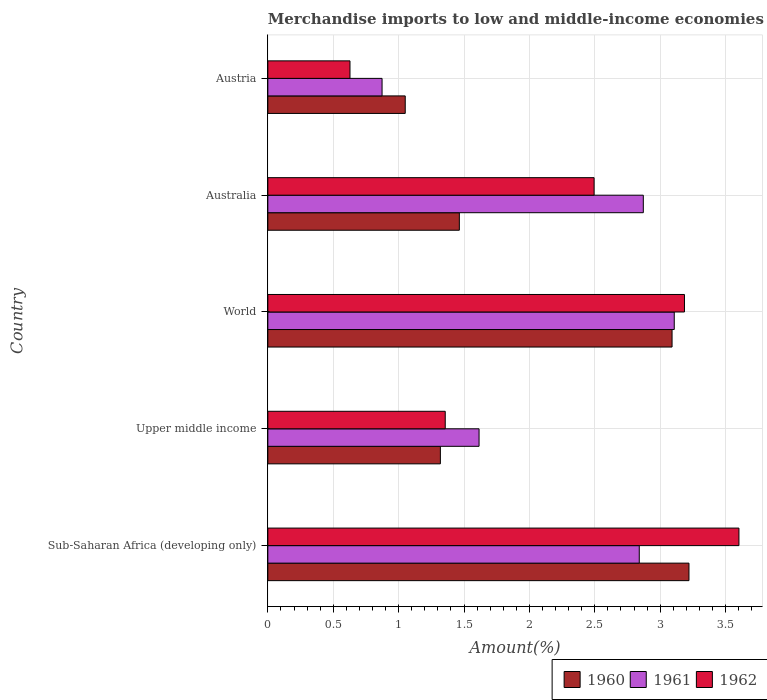How many different coloured bars are there?
Make the answer very short. 3. How many bars are there on the 2nd tick from the bottom?
Keep it short and to the point. 3. What is the label of the 2nd group of bars from the top?
Offer a very short reply. Australia. In how many cases, is the number of bars for a given country not equal to the number of legend labels?
Offer a very short reply. 0. What is the percentage of amount earned from merchandise imports in 1962 in Upper middle income?
Your answer should be very brief. 1.36. Across all countries, what is the maximum percentage of amount earned from merchandise imports in 1961?
Provide a succinct answer. 3.11. Across all countries, what is the minimum percentage of amount earned from merchandise imports in 1962?
Ensure brevity in your answer.  0.63. In which country was the percentage of amount earned from merchandise imports in 1960 minimum?
Ensure brevity in your answer.  Austria. What is the total percentage of amount earned from merchandise imports in 1961 in the graph?
Make the answer very short. 11.31. What is the difference between the percentage of amount earned from merchandise imports in 1960 in Australia and that in Austria?
Ensure brevity in your answer.  0.41. What is the difference between the percentage of amount earned from merchandise imports in 1960 in Upper middle income and the percentage of amount earned from merchandise imports in 1962 in Sub-Saharan Africa (developing only)?
Your answer should be compact. -2.28. What is the average percentage of amount earned from merchandise imports in 1961 per country?
Offer a very short reply. 2.26. What is the difference between the percentage of amount earned from merchandise imports in 1962 and percentage of amount earned from merchandise imports in 1960 in World?
Offer a very short reply. 0.09. In how many countries, is the percentage of amount earned from merchandise imports in 1962 greater than 2.3 %?
Offer a very short reply. 3. What is the ratio of the percentage of amount earned from merchandise imports in 1960 in Australia to that in Sub-Saharan Africa (developing only)?
Make the answer very short. 0.45. Is the difference between the percentage of amount earned from merchandise imports in 1962 in Australia and Upper middle income greater than the difference between the percentage of amount earned from merchandise imports in 1960 in Australia and Upper middle income?
Provide a succinct answer. Yes. What is the difference between the highest and the second highest percentage of amount earned from merchandise imports in 1962?
Provide a succinct answer. 0.42. What is the difference between the highest and the lowest percentage of amount earned from merchandise imports in 1961?
Your answer should be very brief. 2.23. What does the 3rd bar from the bottom in Australia represents?
Your response must be concise. 1962. How many bars are there?
Keep it short and to the point. 15. Are all the bars in the graph horizontal?
Your response must be concise. Yes. What is the difference between two consecutive major ticks on the X-axis?
Keep it short and to the point. 0.5. Are the values on the major ticks of X-axis written in scientific E-notation?
Ensure brevity in your answer.  No. Does the graph contain any zero values?
Provide a short and direct response. No. Where does the legend appear in the graph?
Make the answer very short. Bottom right. How many legend labels are there?
Your answer should be very brief. 3. How are the legend labels stacked?
Keep it short and to the point. Horizontal. What is the title of the graph?
Keep it short and to the point. Merchandise imports to low and middle-income economies in North Africa. What is the label or title of the X-axis?
Offer a very short reply. Amount(%). What is the label or title of the Y-axis?
Offer a very short reply. Country. What is the Amount(%) in 1960 in Sub-Saharan Africa (developing only)?
Keep it short and to the point. 3.22. What is the Amount(%) in 1961 in Sub-Saharan Africa (developing only)?
Your answer should be very brief. 2.84. What is the Amount(%) of 1962 in Sub-Saharan Africa (developing only)?
Provide a short and direct response. 3.6. What is the Amount(%) in 1960 in Upper middle income?
Keep it short and to the point. 1.32. What is the Amount(%) in 1961 in Upper middle income?
Your answer should be very brief. 1.62. What is the Amount(%) in 1962 in Upper middle income?
Keep it short and to the point. 1.36. What is the Amount(%) of 1960 in World?
Keep it short and to the point. 3.09. What is the Amount(%) in 1961 in World?
Your response must be concise. 3.11. What is the Amount(%) of 1962 in World?
Your answer should be very brief. 3.19. What is the Amount(%) of 1960 in Australia?
Make the answer very short. 1.46. What is the Amount(%) of 1961 in Australia?
Keep it short and to the point. 2.87. What is the Amount(%) in 1962 in Australia?
Provide a succinct answer. 2.49. What is the Amount(%) of 1960 in Austria?
Give a very brief answer. 1.05. What is the Amount(%) in 1961 in Austria?
Make the answer very short. 0.87. What is the Amount(%) in 1962 in Austria?
Provide a succinct answer. 0.63. Across all countries, what is the maximum Amount(%) in 1960?
Make the answer very short. 3.22. Across all countries, what is the maximum Amount(%) in 1961?
Your response must be concise. 3.11. Across all countries, what is the maximum Amount(%) of 1962?
Give a very brief answer. 3.6. Across all countries, what is the minimum Amount(%) of 1960?
Ensure brevity in your answer.  1.05. Across all countries, what is the minimum Amount(%) of 1961?
Offer a very short reply. 0.87. Across all countries, what is the minimum Amount(%) of 1962?
Give a very brief answer. 0.63. What is the total Amount(%) of 1960 in the graph?
Your answer should be very brief. 10.14. What is the total Amount(%) of 1961 in the graph?
Your response must be concise. 11.31. What is the total Amount(%) of 1962 in the graph?
Your answer should be very brief. 11.27. What is the difference between the Amount(%) of 1960 in Sub-Saharan Africa (developing only) and that in Upper middle income?
Make the answer very short. 1.9. What is the difference between the Amount(%) of 1961 in Sub-Saharan Africa (developing only) and that in Upper middle income?
Ensure brevity in your answer.  1.23. What is the difference between the Amount(%) in 1962 in Sub-Saharan Africa (developing only) and that in Upper middle income?
Give a very brief answer. 2.25. What is the difference between the Amount(%) in 1960 in Sub-Saharan Africa (developing only) and that in World?
Make the answer very short. 0.13. What is the difference between the Amount(%) in 1961 in Sub-Saharan Africa (developing only) and that in World?
Ensure brevity in your answer.  -0.27. What is the difference between the Amount(%) in 1962 in Sub-Saharan Africa (developing only) and that in World?
Give a very brief answer. 0.42. What is the difference between the Amount(%) of 1960 in Sub-Saharan Africa (developing only) and that in Australia?
Your answer should be very brief. 1.76. What is the difference between the Amount(%) in 1961 in Sub-Saharan Africa (developing only) and that in Australia?
Your answer should be very brief. -0.03. What is the difference between the Amount(%) in 1962 in Sub-Saharan Africa (developing only) and that in Australia?
Your answer should be compact. 1.11. What is the difference between the Amount(%) of 1960 in Sub-Saharan Africa (developing only) and that in Austria?
Give a very brief answer. 2.17. What is the difference between the Amount(%) of 1961 in Sub-Saharan Africa (developing only) and that in Austria?
Give a very brief answer. 1.97. What is the difference between the Amount(%) of 1962 in Sub-Saharan Africa (developing only) and that in Austria?
Provide a short and direct response. 2.97. What is the difference between the Amount(%) of 1960 in Upper middle income and that in World?
Give a very brief answer. -1.77. What is the difference between the Amount(%) in 1961 in Upper middle income and that in World?
Offer a terse response. -1.49. What is the difference between the Amount(%) of 1962 in Upper middle income and that in World?
Give a very brief answer. -1.83. What is the difference between the Amount(%) of 1960 in Upper middle income and that in Australia?
Give a very brief answer. -0.14. What is the difference between the Amount(%) of 1961 in Upper middle income and that in Australia?
Provide a short and direct response. -1.26. What is the difference between the Amount(%) of 1962 in Upper middle income and that in Australia?
Make the answer very short. -1.14. What is the difference between the Amount(%) of 1960 in Upper middle income and that in Austria?
Your response must be concise. 0.27. What is the difference between the Amount(%) of 1961 in Upper middle income and that in Austria?
Give a very brief answer. 0.74. What is the difference between the Amount(%) in 1962 in Upper middle income and that in Austria?
Provide a short and direct response. 0.73. What is the difference between the Amount(%) in 1960 in World and that in Australia?
Offer a terse response. 1.63. What is the difference between the Amount(%) of 1961 in World and that in Australia?
Keep it short and to the point. 0.24. What is the difference between the Amount(%) of 1962 in World and that in Australia?
Give a very brief answer. 0.69. What is the difference between the Amount(%) of 1960 in World and that in Austria?
Ensure brevity in your answer.  2.04. What is the difference between the Amount(%) of 1961 in World and that in Austria?
Your answer should be very brief. 2.23. What is the difference between the Amount(%) in 1962 in World and that in Austria?
Keep it short and to the point. 2.56. What is the difference between the Amount(%) of 1960 in Australia and that in Austria?
Offer a very short reply. 0.41. What is the difference between the Amount(%) of 1961 in Australia and that in Austria?
Your answer should be compact. 2. What is the difference between the Amount(%) in 1962 in Australia and that in Austria?
Your answer should be very brief. 1.87. What is the difference between the Amount(%) in 1960 in Sub-Saharan Africa (developing only) and the Amount(%) in 1961 in Upper middle income?
Offer a very short reply. 1.61. What is the difference between the Amount(%) in 1960 in Sub-Saharan Africa (developing only) and the Amount(%) in 1962 in Upper middle income?
Ensure brevity in your answer.  1.86. What is the difference between the Amount(%) of 1961 in Sub-Saharan Africa (developing only) and the Amount(%) of 1962 in Upper middle income?
Your answer should be very brief. 1.48. What is the difference between the Amount(%) of 1960 in Sub-Saharan Africa (developing only) and the Amount(%) of 1961 in World?
Offer a very short reply. 0.11. What is the difference between the Amount(%) in 1960 in Sub-Saharan Africa (developing only) and the Amount(%) in 1962 in World?
Your answer should be compact. 0.03. What is the difference between the Amount(%) in 1961 in Sub-Saharan Africa (developing only) and the Amount(%) in 1962 in World?
Your answer should be compact. -0.35. What is the difference between the Amount(%) of 1960 in Sub-Saharan Africa (developing only) and the Amount(%) of 1961 in Australia?
Offer a terse response. 0.35. What is the difference between the Amount(%) in 1960 in Sub-Saharan Africa (developing only) and the Amount(%) in 1962 in Australia?
Ensure brevity in your answer.  0.73. What is the difference between the Amount(%) of 1961 in Sub-Saharan Africa (developing only) and the Amount(%) of 1962 in Australia?
Offer a terse response. 0.35. What is the difference between the Amount(%) of 1960 in Sub-Saharan Africa (developing only) and the Amount(%) of 1961 in Austria?
Make the answer very short. 2.35. What is the difference between the Amount(%) in 1960 in Sub-Saharan Africa (developing only) and the Amount(%) in 1962 in Austria?
Your answer should be compact. 2.59. What is the difference between the Amount(%) in 1961 in Sub-Saharan Africa (developing only) and the Amount(%) in 1962 in Austria?
Provide a succinct answer. 2.21. What is the difference between the Amount(%) of 1960 in Upper middle income and the Amount(%) of 1961 in World?
Your answer should be very brief. -1.79. What is the difference between the Amount(%) of 1960 in Upper middle income and the Amount(%) of 1962 in World?
Make the answer very short. -1.87. What is the difference between the Amount(%) of 1961 in Upper middle income and the Amount(%) of 1962 in World?
Your response must be concise. -1.57. What is the difference between the Amount(%) in 1960 in Upper middle income and the Amount(%) in 1961 in Australia?
Give a very brief answer. -1.55. What is the difference between the Amount(%) of 1960 in Upper middle income and the Amount(%) of 1962 in Australia?
Your answer should be very brief. -1.18. What is the difference between the Amount(%) of 1961 in Upper middle income and the Amount(%) of 1962 in Australia?
Give a very brief answer. -0.88. What is the difference between the Amount(%) in 1960 in Upper middle income and the Amount(%) in 1961 in Austria?
Your response must be concise. 0.45. What is the difference between the Amount(%) in 1960 in Upper middle income and the Amount(%) in 1962 in Austria?
Provide a succinct answer. 0.69. What is the difference between the Amount(%) in 1961 in Upper middle income and the Amount(%) in 1962 in Austria?
Provide a succinct answer. 0.99. What is the difference between the Amount(%) in 1960 in World and the Amount(%) in 1961 in Australia?
Make the answer very short. 0.22. What is the difference between the Amount(%) of 1960 in World and the Amount(%) of 1962 in Australia?
Your answer should be very brief. 0.6. What is the difference between the Amount(%) in 1961 in World and the Amount(%) in 1962 in Australia?
Offer a terse response. 0.61. What is the difference between the Amount(%) in 1960 in World and the Amount(%) in 1961 in Austria?
Make the answer very short. 2.22. What is the difference between the Amount(%) in 1960 in World and the Amount(%) in 1962 in Austria?
Ensure brevity in your answer.  2.46. What is the difference between the Amount(%) in 1961 in World and the Amount(%) in 1962 in Austria?
Keep it short and to the point. 2.48. What is the difference between the Amount(%) in 1960 in Australia and the Amount(%) in 1961 in Austria?
Your answer should be very brief. 0.59. What is the difference between the Amount(%) of 1960 in Australia and the Amount(%) of 1962 in Austria?
Your answer should be compact. 0.84. What is the difference between the Amount(%) in 1961 in Australia and the Amount(%) in 1962 in Austria?
Offer a very short reply. 2.24. What is the average Amount(%) in 1960 per country?
Provide a short and direct response. 2.03. What is the average Amount(%) in 1961 per country?
Offer a terse response. 2.26. What is the average Amount(%) of 1962 per country?
Your answer should be very brief. 2.25. What is the difference between the Amount(%) in 1960 and Amount(%) in 1961 in Sub-Saharan Africa (developing only)?
Provide a short and direct response. 0.38. What is the difference between the Amount(%) of 1960 and Amount(%) of 1962 in Sub-Saharan Africa (developing only)?
Provide a short and direct response. -0.38. What is the difference between the Amount(%) of 1961 and Amount(%) of 1962 in Sub-Saharan Africa (developing only)?
Make the answer very short. -0.76. What is the difference between the Amount(%) of 1960 and Amount(%) of 1961 in Upper middle income?
Provide a succinct answer. -0.3. What is the difference between the Amount(%) of 1960 and Amount(%) of 1962 in Upper middle income?
Give a very brief answer. -0.04. What is the difference between the Amount(%) of 1961 and Amount(%) of 1962 in Upper middle income?
Your answer should be compact. 0.26. What is the difference between the Amount(%) of 1960 and Amount(%) of 1961 in World?
Your answer should be compact. -0.02. What is the difference between the Amount(%) in 1960 and Amount(%) in 1962 in World?
Your answer should be compact. -0.1. What is the difference between the Amount(%) of 1961 and Amount(%) of 1962 in World?
Make the answer very short. -0.08. What is the difference between the Amount(%) of 1960 and Amount(%) of 1961 in Australia?
Offer a terse response. -1.41. What is the difference between the Amount(%) of 1960 and Amount(%) of 1962 in Australia?
Give a very brief answer. -1.03. What is the difference between the Amount(%) in 1961 and Amount(%) in 1962 in Australia?
Your answer should be compact. 0.38. What is the difference between the Amount(%) of 1960 and Amount(%) of 1961 in Austria?
Provide a short and direct response. 0.18. What is the difference between the Amount(%) in 1960 and Amount(%) in 1962 in Austria?
Offer a terse response. 0.42. What is the difference between the Amount(%) of 1961 and Amount(%) of 1962 in Austria?
Offer a very short reply. 0.25. What is the ratio of the Amount(%) in 1960 in Sub-Saharan Africa (developing only) to that in Upper middle income?
Your answer should be very brief. 2.44. What is the ratio of the Amount(%) of 1961 in Sub-Saharan Africa (developing only) to that in Upper middle income?
Your answer should be compact. 1.76. What is the ratio of the Amount(%) of 1962 in Sub-Saharan Africa (developing only) to that in Upper middle income?
Offer a terse response. 2.66. What is the ratio of the Amount(%) of 1960 in Sub-Saharan Africa (developing only) to that in World?
Offer a terse response. 1.04. What is the ratio of the Amount(%) in 1961 in Sub-Saharan Africa (developing only) to that in World?
Make the answer very short. 0.91. What is the ratio of the Amount(%) in 1962 in Sub-Saharan Africa (developing only) to that in World?
Make the answer very short. 1.13. What is the ratio of the Amount(%) of 1960 in Sub-Saharan Africa (developing only) to that in Australia?
Your response must be concise. 2.2. What is the ratio of the Amount(%) in 1962 in Sub-Saharan Africa (developing only) to that in Australia?
Offer a terse response. 1.44. What is the ratio of the Amount(%) of 1960 in Sub-Saharan Africa (developing only) to that in Austria?
Your answer should be very brief. 3.07. What is the ratio of the Amount(%) of 1961 in Sub-Saharan Africa (developing only) to that in Austria?
Your answer should be compact. 3.25. What is the ratio of the Amount(%) in 1962 in Sub-Saharan Africa (developing only) to that in Austria?
Your answer should be very brief. 5.74. What is the ratio of the Amount(%) in 1960 in Upper middle income to that in World?
Give a very brief answer. 0.43. What is the ratio of the Amount(%) in 1961 in Upper middle income to that in World?
Your answer should be compact. 0.52. What is the ratio of the Amount(%) of 1962 in Upper middle income to that in World?
Make the answer very short. 0.43. What is the ratio of the Amount(%) of 1960 in Upper middle income to that in Australia?
Keep it short and to the point. 0.9. What is the ratio of the Amount(%) of 1961 in Upper middle income to that in Australia?
Your answer should be compact. 0.56. What is the ratio of the Amount(%) of 1962 in Upper middle income to that in Australia?
Make the answer very short. 0.54. What is the ratio of the Amount(%) of 1960 in Upper middle income to that in Austria?
Keep it short and to the point. 1.26. What is the ratio of the Amount(%) in 1961 in Upper middle income to that in Austria?
Your answer should be compact. 1.85. What is the ratio of the Amount(%) in 1962 in Upper middle income to that in Austria?
Give a very brief answer. 2.16. What is the ratio of the Amount(%) in 1960 in World to that in Australia?
Your answer should be compact. 2.11. What is the ratio of the Amount(%) in 1961 in World to that in Australia?
Make the answer very short. 1.08. What is the ratio of the Amount(%) of 1962 in World to that in Australia?
Provide a short and direct response. 1.28. What is the ratio of the Amount(%) of 1960 in World to that in Austria?
Give a very brief answer. 2.94. What is the ratio of the Amount(%) of 1961 in World to that in Austria?
Give a very brief answer. 3.56. What is the ratio of the Amount(%) of 1962 in World to that in Austria?
Give a very brief answer. 5.07. What is the ratio of the Amount(%) in 1960 in Australia to that in Austria?
Make the answer very short. 1.39. What is the ratio of the Amount(%) in 1961 in Australia to that in Austria?
Provide a succinct answer. 3.29. What is the ratio of the Amount(%) in 1962 in Australia to that in Austria?
Offer a terse response. 3.97. What is the difference between the highest and the second highest Amount(%) of 1960?
Keep it short and to the point. 0.13. What is the difference between the highest and the second highest Amount(%) in 1961?
Offer a terse response. 0.24. What is the difference between the highest and the second highest Amount(%) in 1962?
Provide a short and direct response. 0.42. What is the difference between the highest and the lowest Amount(%) of 1960?
Ensure brevity in your answer.  2.17. What is the difference between the highest and the lowest Amount(%) of 1961?
Give a very brief answer. 2.23. What is the difference between the highest and the lowest Amount(%) in 1962?
Your answer should be very brief. 2.97. 